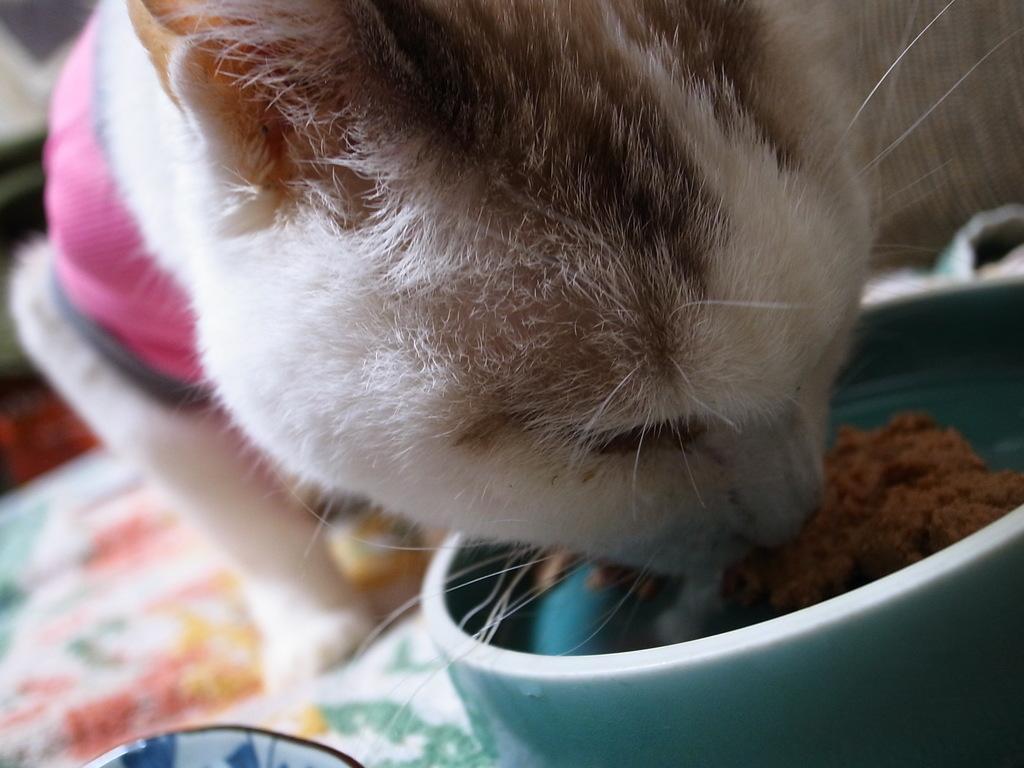Please provide a concise description of this image. This image is taken indoors. At the bottom of the image there is a table with a tablecloth, a cup and a bowl with food on it. In the middle of the image there is a cat on the table and the cat is eating food from the bowl. 